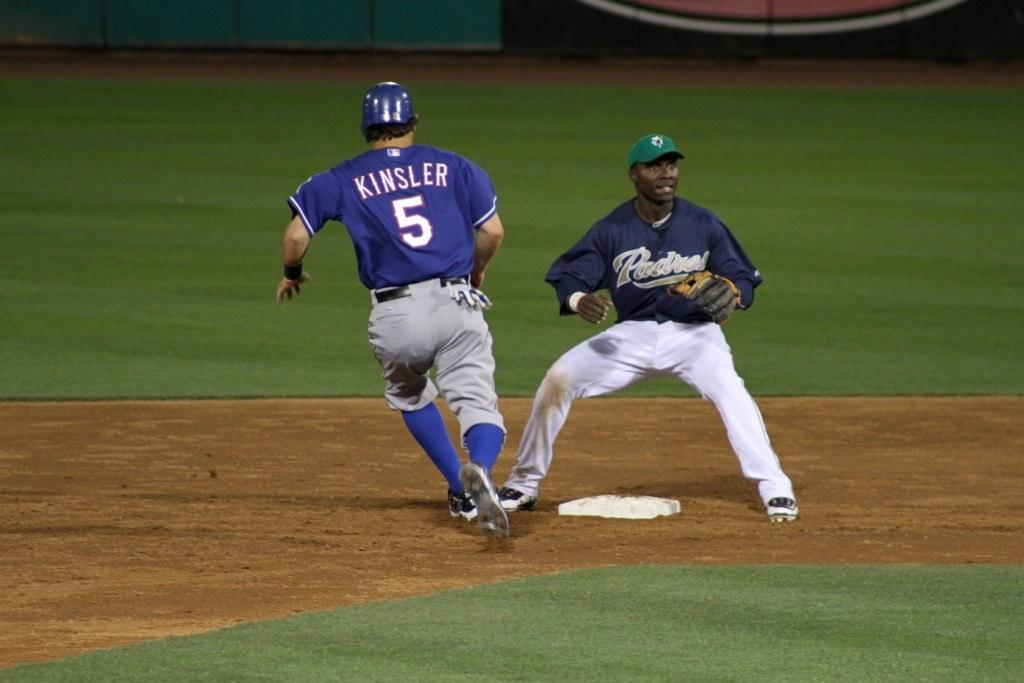Provide a one-sentence caption for the provided image. Kinsler in the number 5 jersey appears to be safe. 